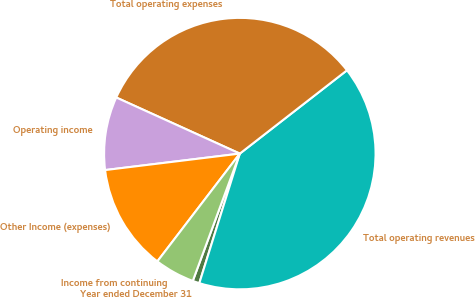Convert chart. <chart><loc_0><loc_0><loc_500><loc_500><pie_chart><fcel>Year ended December 31<fcel>Total operating revenues<fcel>Total operating expenses<fcel>Operating income<fcel>Other Income (expenses)<fcel>Income from continuing<nl><fcel>0.81%<fcel>40.34%<fcel>32.7%<fcel>8.72%<fcel>12.67%<fcel>4.76%<nl></chart> 